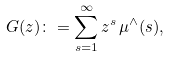Convert formula to latex. <formula><loc_0><loc_0><loc_500><loc_500>G ( z ) \colon = \sum _ { s = 1 } ^ { \infty } z ^ { s } \, \mu ^ { \wedge } ( s ) ,</formula> 